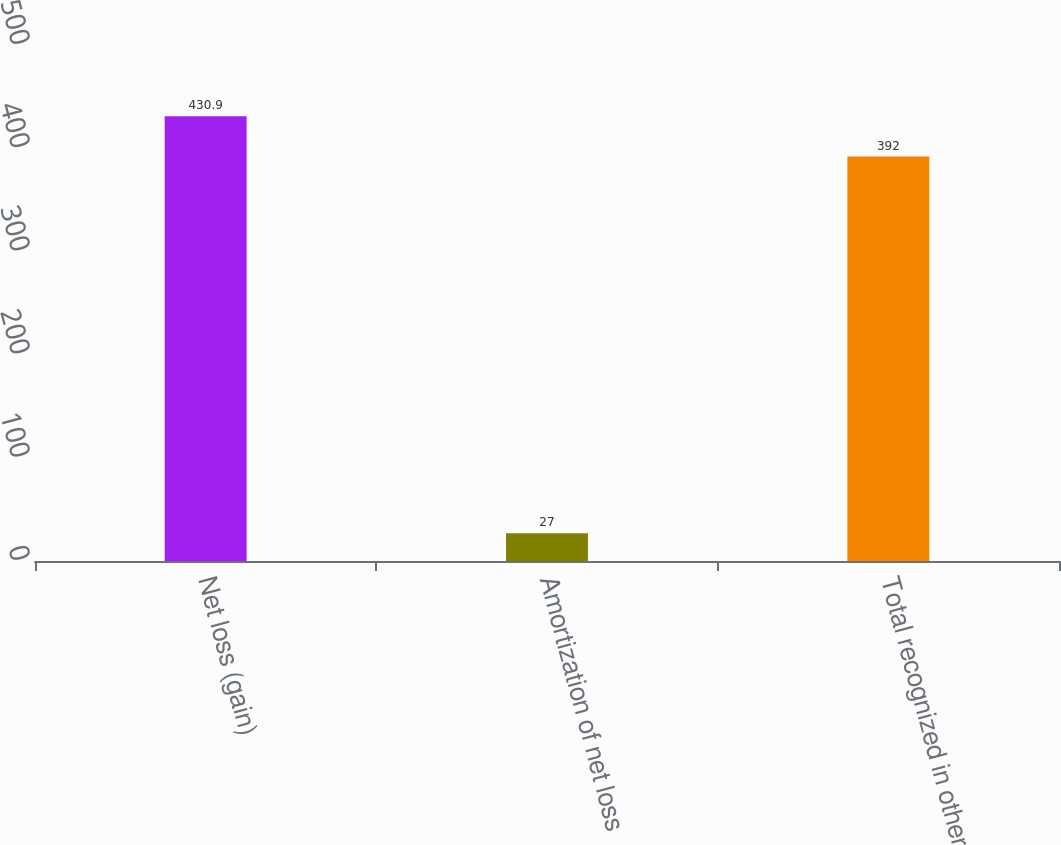<chart> <loc_0><loc_0><loc_500><loc_500><bar_chart><fcel>Net loss (gain)<fcel>Amortization of net loss<fcel>Total recognized in other<nl><fcel>430.9<fcel>27<fcel>392<nl></chart> 